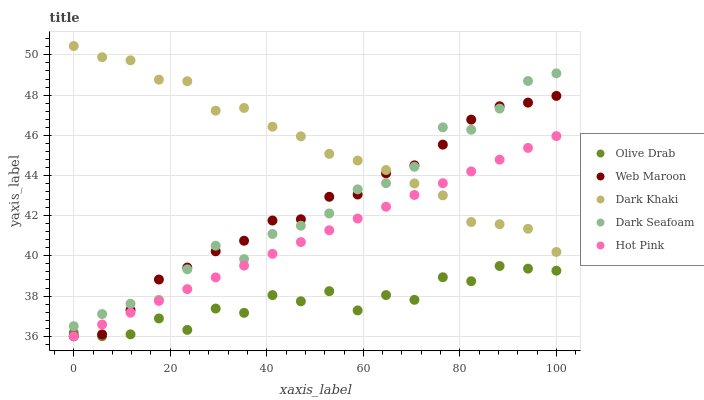Does Olive Drab have the minimum area under the curve?
Answer yes or no. Yes. Does Dark Khaki have the maximum area under the curve?
Answer yes or no. Yes. Does Dark Seafoam have the minimum area under the curve?
Answer yes or no. No. Does Dark Seafoam have the maximum area under the curve?
Answer yes or no. No. Is Hot Pink the smoothest?
Answer yes or no. Yes. Is Olive Drab the roughest?
Answer yes or no. Yes. Is Dark Seafoam the smoothest?
Answer yes or no. No. Is Dark Seafoam the roughest?
Answer yes or no. No. Does Hot Pink have the lowest value?
Answer yes or no. Yes. Does Dark Seafoam have the lowest value?
Answer yes or no. No. Does Dark Khaki have the highest value?
Answer yes or no. Yes. Does Dark Seafoam have the highest value?
Answer yes or no. No. Is Olive Drab less than Dark Seafoam?
Answer yes or no. Yes. Is Dark Seafoam greater than Hot Pink?
Answer yes or no. Yes. Does Hot Pink intersect Olive Drab?
Answer yes or no. Yes. Is Hot Pink less than Olive Drab?
Answer yes or no. No. Is Hot Pink greater than Olive Drab?
Answer yes or no. No. Does Olive Drab intersect Dark Seafoam?
Answer yes or no. No. 